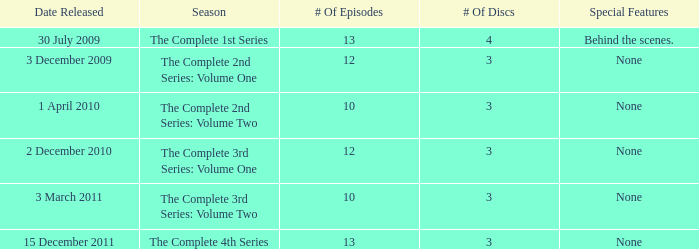How many discs for the complete 4th series? 3.0. 